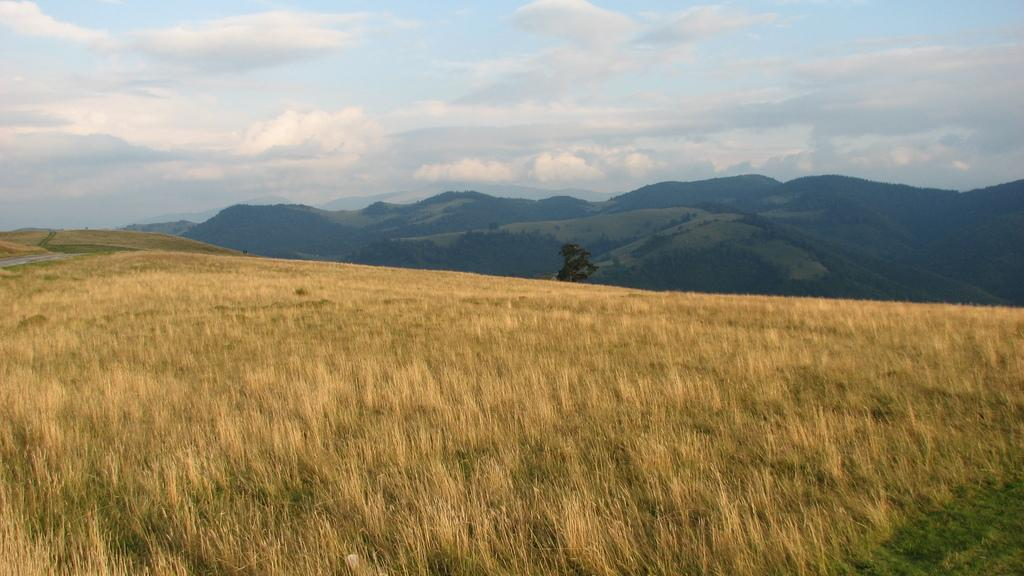What type of natural formation can be seen in the image? There are mountains in the image. What type of plant is present in the image? There is a tree in the image. What is the condition of the sky in the background of the image? The sky is cloudy in the background of the image. What type of thread is being used to sew the loss in the image? There is no loss or thread present in the image; it features mountains, a tree, and a cloudy sky. 